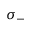<formula> <loc_0><loc_0><loc_500><loc_500>\sigma _ { - }</formula> 